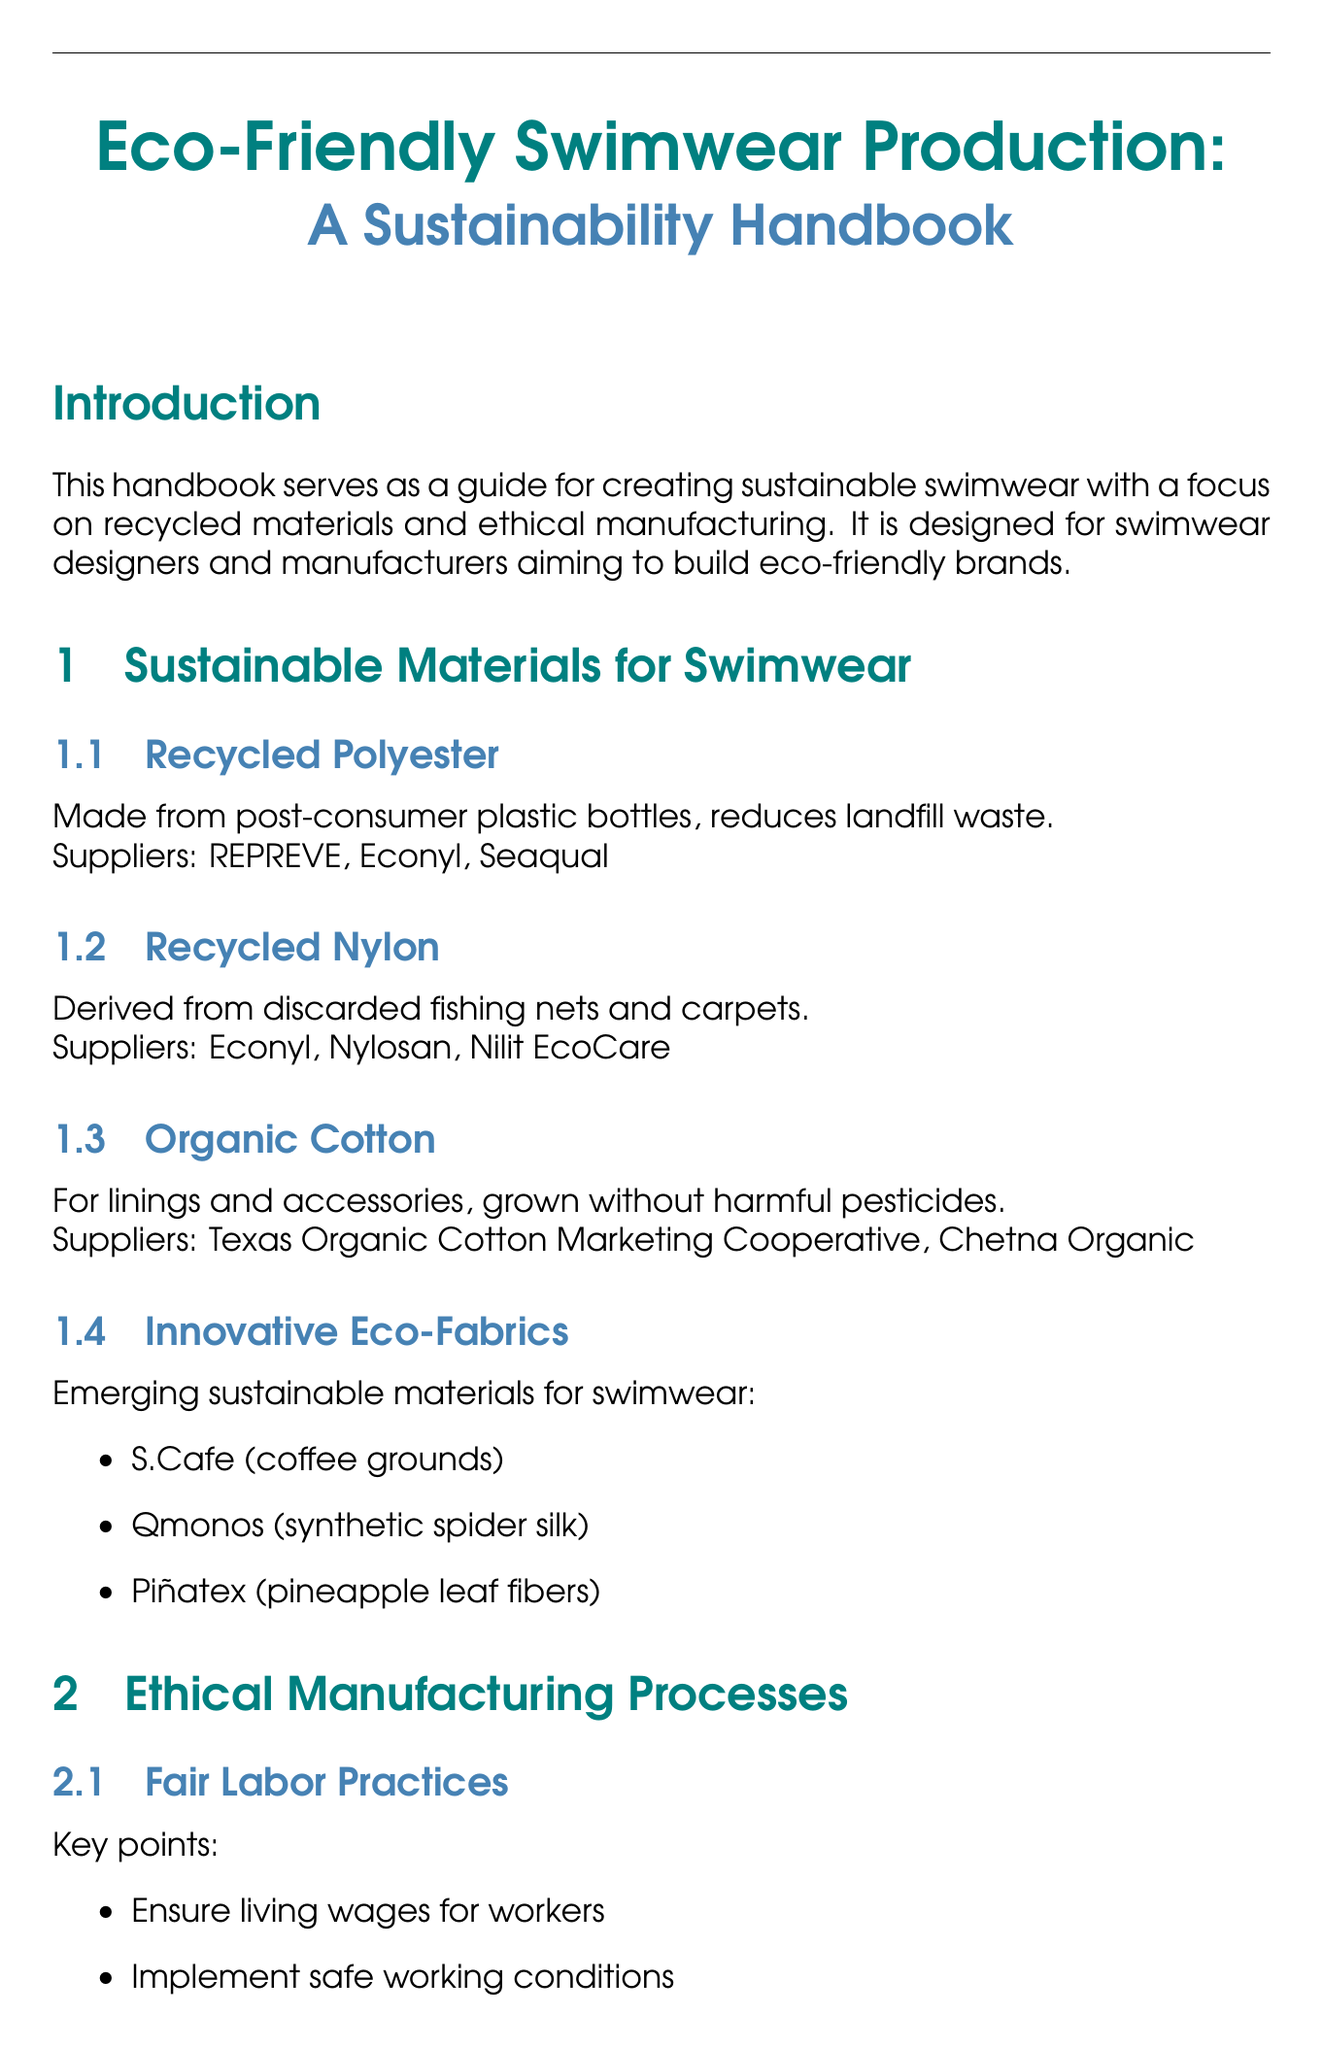What is the purpose of the handbook? The handbook serves as a guide for creating sustainable swimwear with a focus on recycled materials and ethical manufacturing.
Answer: Guide for creating sustainable swimwear Who is the target audience of the manual? The target audience consists of swimwear designers and manufacturers aiming to build eco-friendly brands.
Answer: Swimwear designers and manufacturers Name one supplier of recycled nylon. The document lists several suppliers of recycled nylon, such as Econyl, Nylosan, and Nilit EcoCare.
Answer: Econyl What is one method outlined for sustainable production techniques? The document provides methods such as digital printing, laser cutting, and heat-press bonding.
Answer: Digital printing List one type of eco-friendly packaging material mentioned. The document details several eco-friendly packaging materials, including biodegradable poly bags and recycled cardboard boxes.
Answer: Biodegradable poly bags What does the document suggest for improving supply chain transparency? The handbook recommends using QR codes, blockchain technology, and annual sustainability reports to improve transparency.
Answer: QR codes Which certification is associated with fair labor practices? The document mentions several certifications related to labor practices including Fair Trade Certified and SA8000.
Answer: Fair Trade Certified What is a key takeaway from the conclusion? The conclusion summarizes several key takeaways, one of which is ensuring ethical manufacturing through certifications and best practices.
Answer: Ensure ethical manufacturing through certifications Identify a research initiative for biodegradable swimwear. The document lists research initiatives, including the Fraunhofer Institute for Applied Polymer Research and the University of California, San Diego.
Answer: Fraunhofer Institute for Applied Polymer Research 